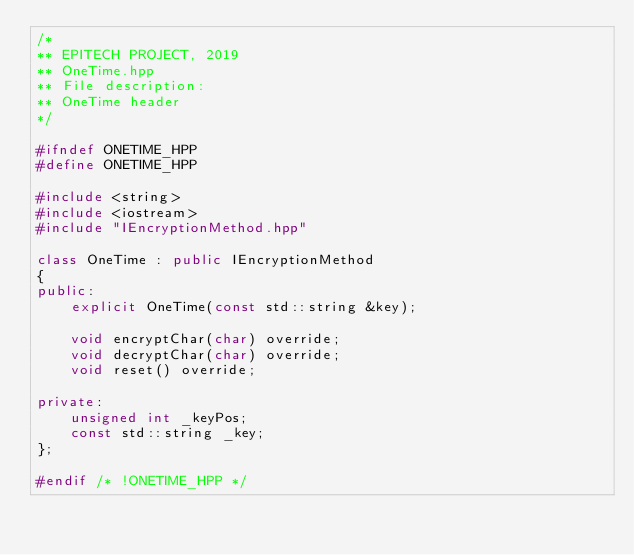<code> <loc_0><loc_0><loc_500><loc_500><_C++_>/*
** EPITECH PROJECT, 2019
** OneTime.hpp
** File description:
** OneTime header
*/

#ifndef ONETIME_HPP
#define ONETIME_HPP

#include <string>
#include <iostream>
#include "IEncryptionMethod.hpp"

class OneTime : public IEncryptionMethod
{
public:
    explicit OneTime(const std::string &key);

    void encryptChar(char) override;
    void decryptChar(char) override;
    void reset() override;

private:
    unsigned int _keyPos;
    const std::string _key;
};

#endif /* !ONETIME_HPP */
</code> 